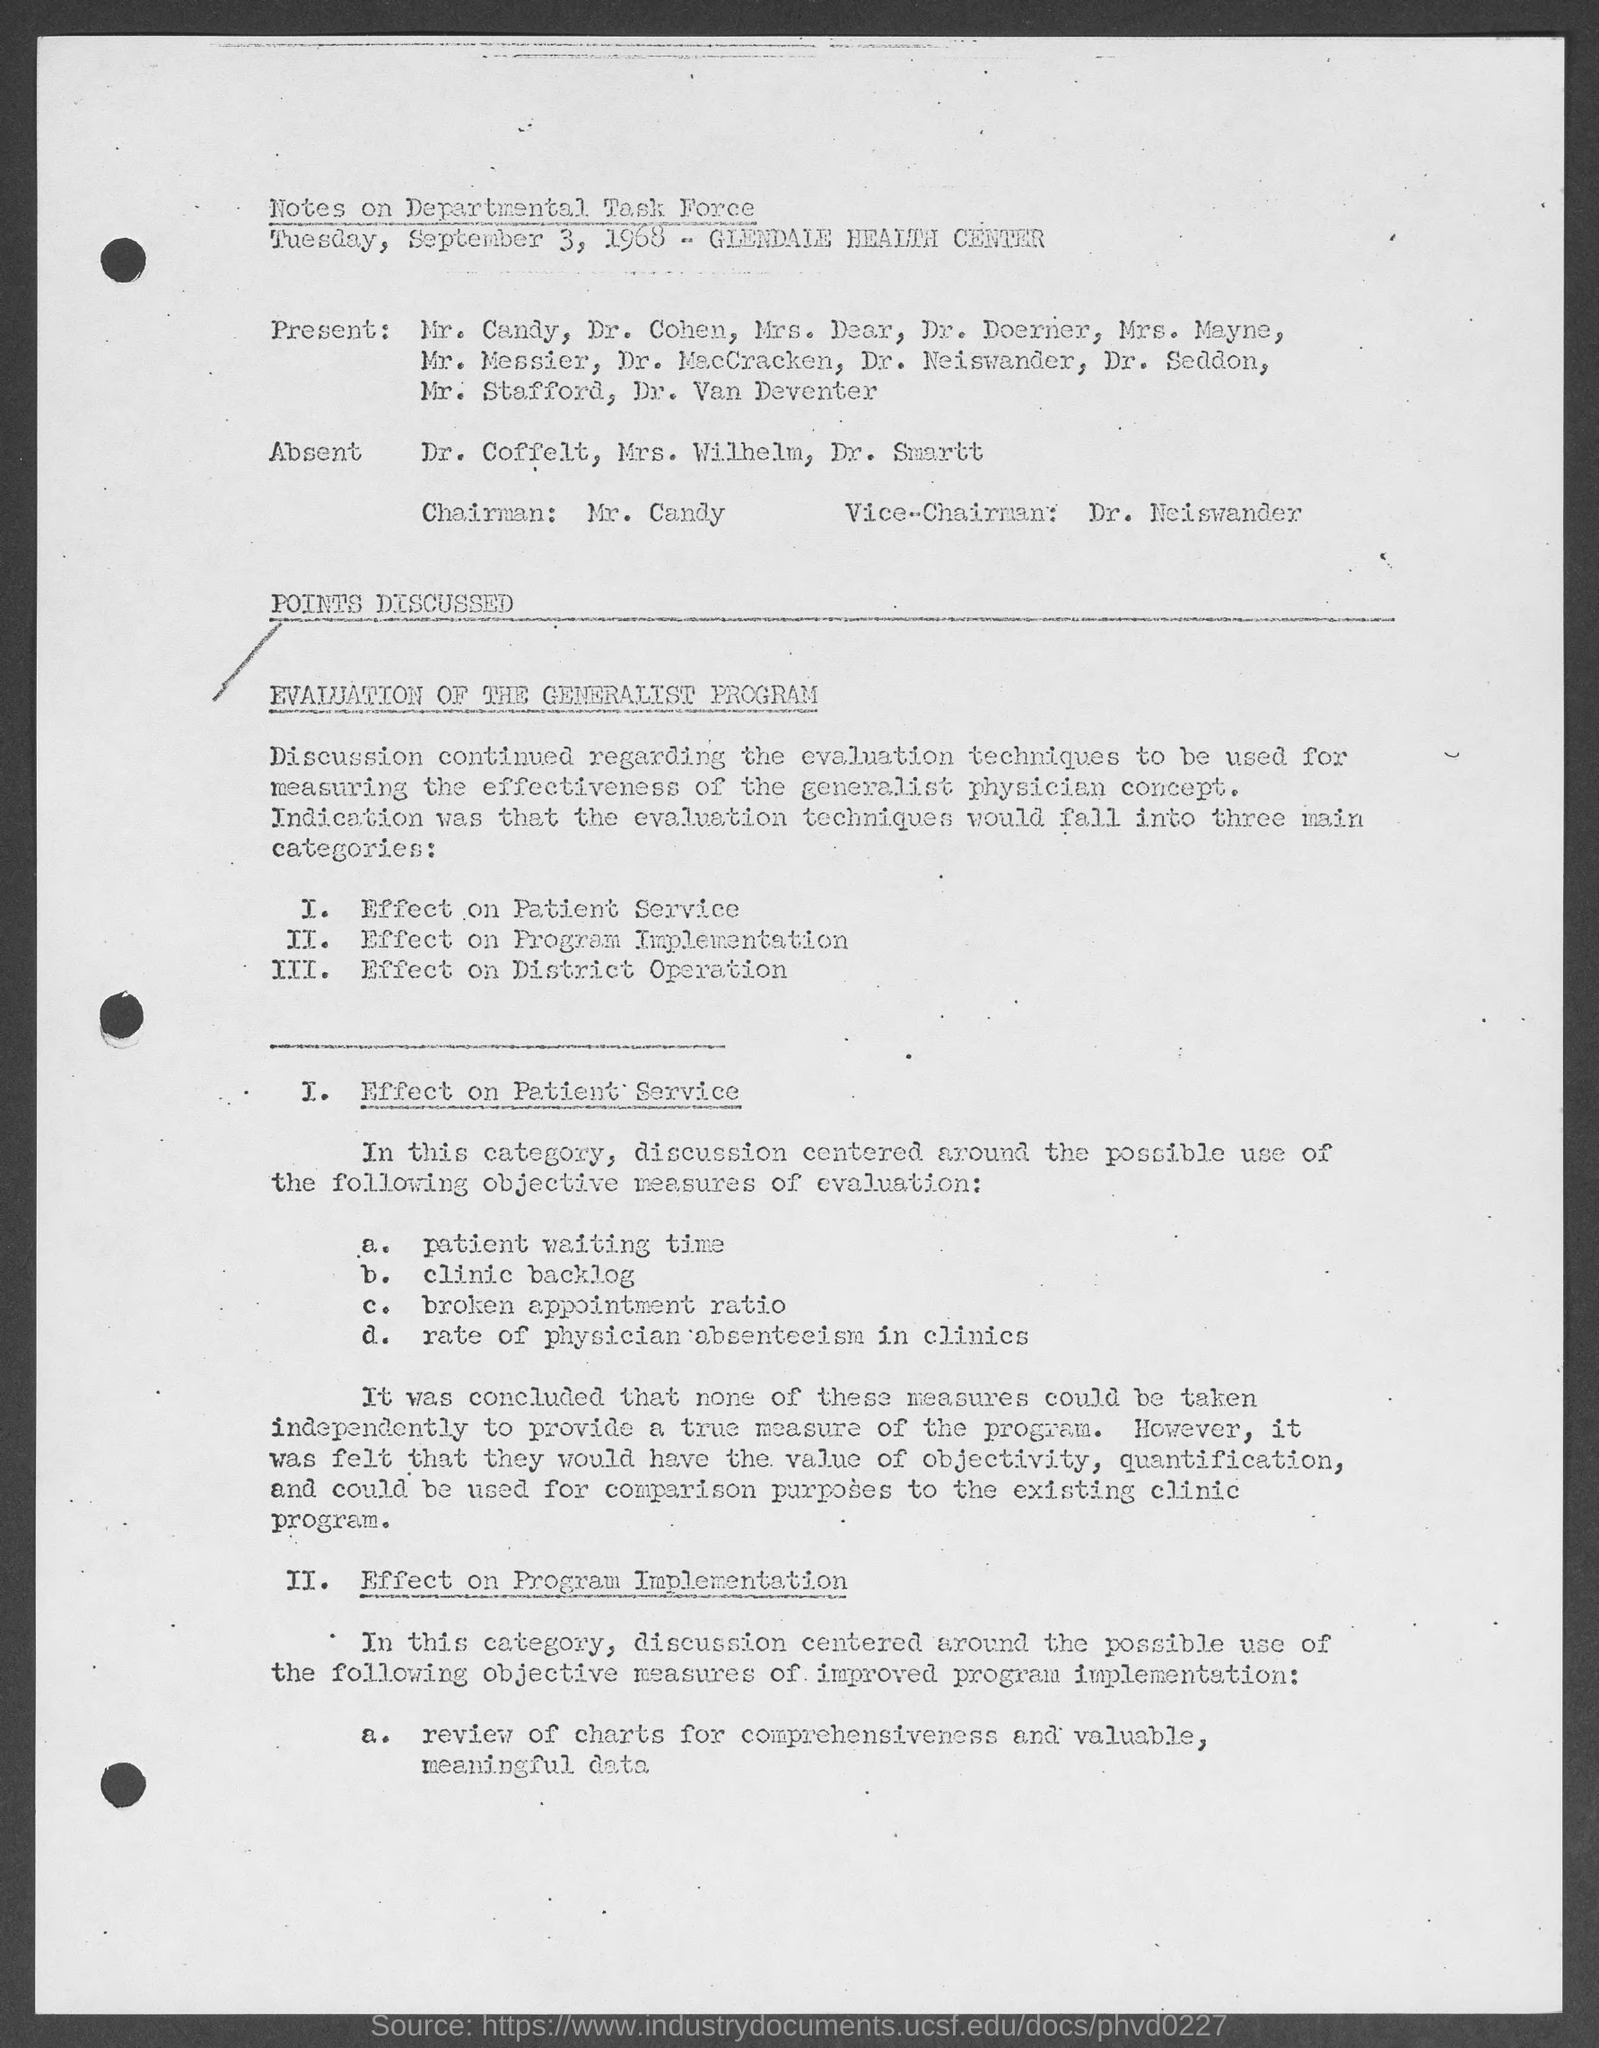Who is the Chairman mentioned in the document?
Provide a succinct answer. Mr. candy. Who is the Vice-Chairman mentioned in the document?
Ensure brevity in your answer.  Dr. neiswander. Who were absent according to the  Notes on Departmental Task Force?
Provide a short and direct response. Dr. coffelt, Mrs. Wilhelm, dr. smartt. 